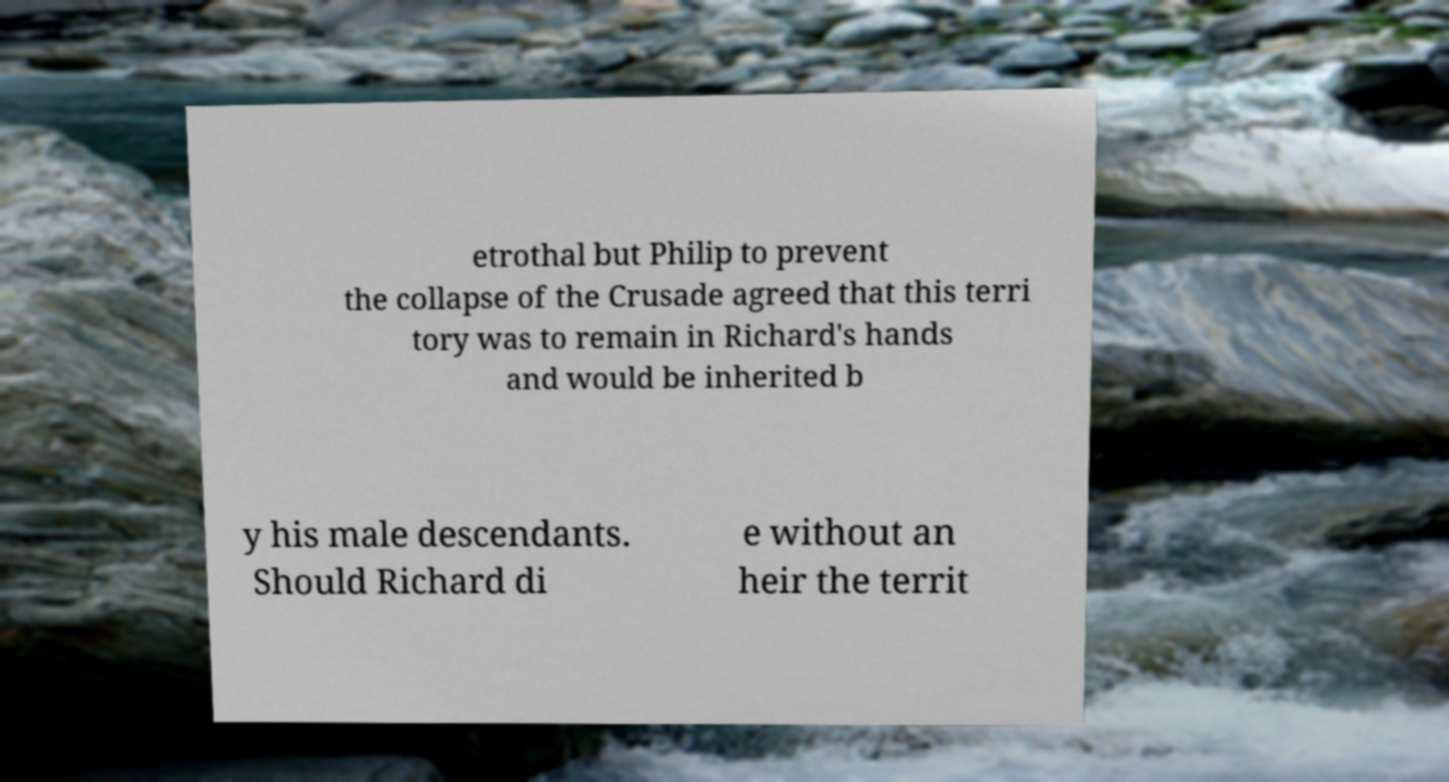For documentation purposes, I need the text within this image transcribed. Could you provide that? etrothal but Philip to prevent the collapse of the Crusade agreed that this terri tory was to remain in Richard's hands and would be inherited b y his male descendants. Should Richard di e without an heir the territ 